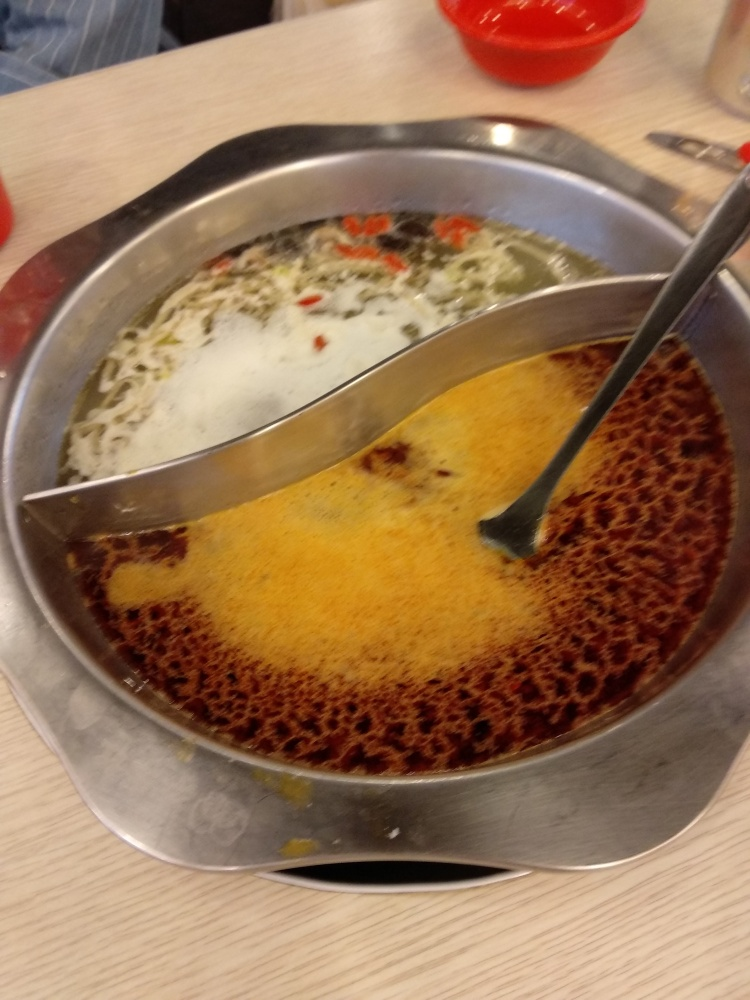Can you guess what dish is being showcased in this image? It appears to be a dish separated down the middle in a yin-yang design, commonly known as a 'hot pot' or 'steamboat'. One side has a clear broth, and the other has a spicy broth. 